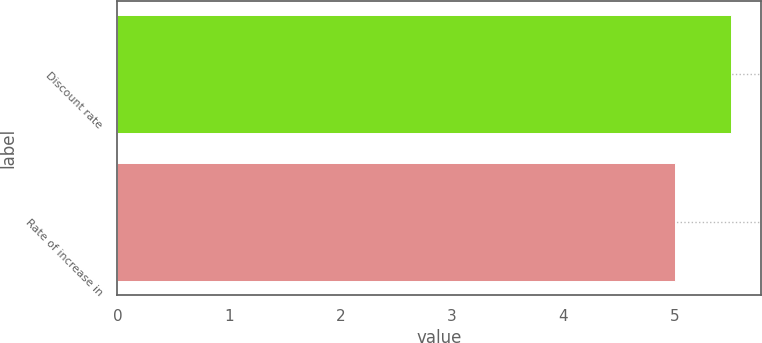Convert chart to OTSL. <chart><loc_0><loc_0><loc_500><loc_500><bar_chart><fcel>Discount rate<fcel>Rate of increase in<nl><fcel>5.5<fcel>5<nl></chart> 